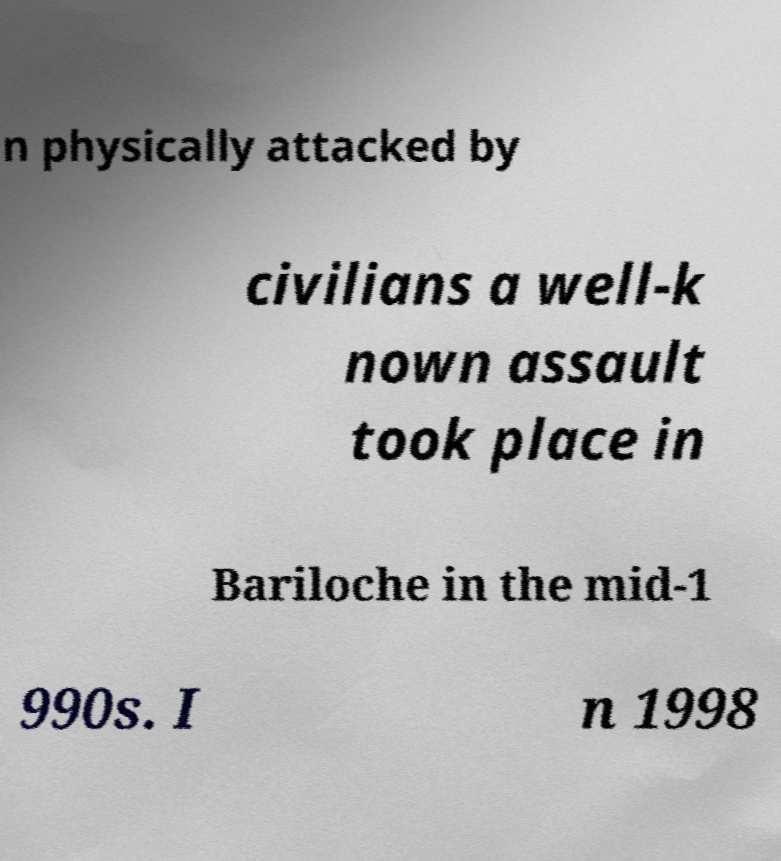Could you extract and type out the text from this image? n physically attacked by civilians a well-k nown assault took place in Bariloche in the mid-1 990s. I n 1998 